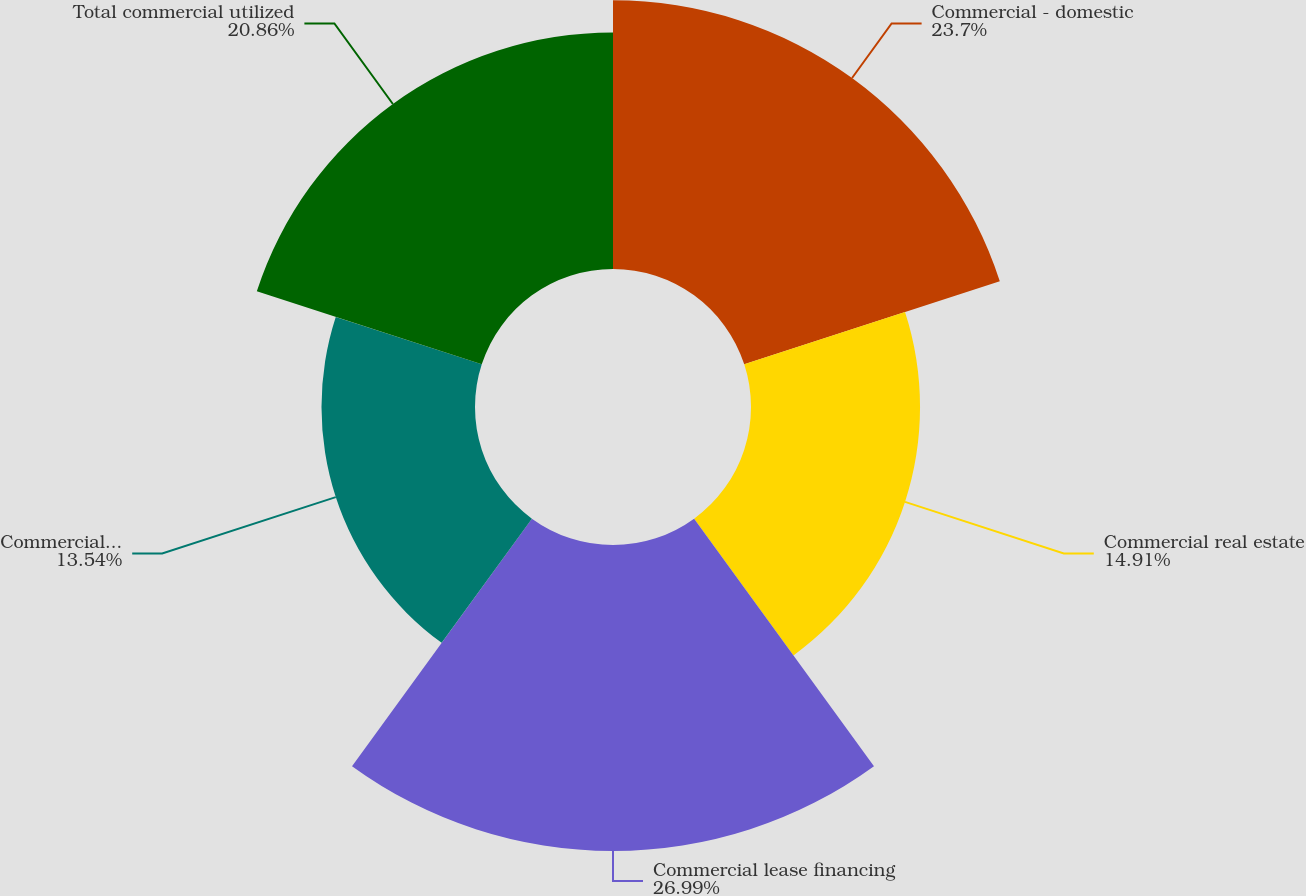<chart> <loc_0><loc_0><loc_500><loc_500><pie_chart><fcel>Commercial - domestic<fcel>Commercial real estate<fcel>Commercial lease financing<fcel>Commercial - foreign<fcel>Total commercial utilized<nl><fcel>23.7%<fcel>14.91%<fcel>26.99%<fcel>13.54%<fcel>20.86%<nl></chart> 